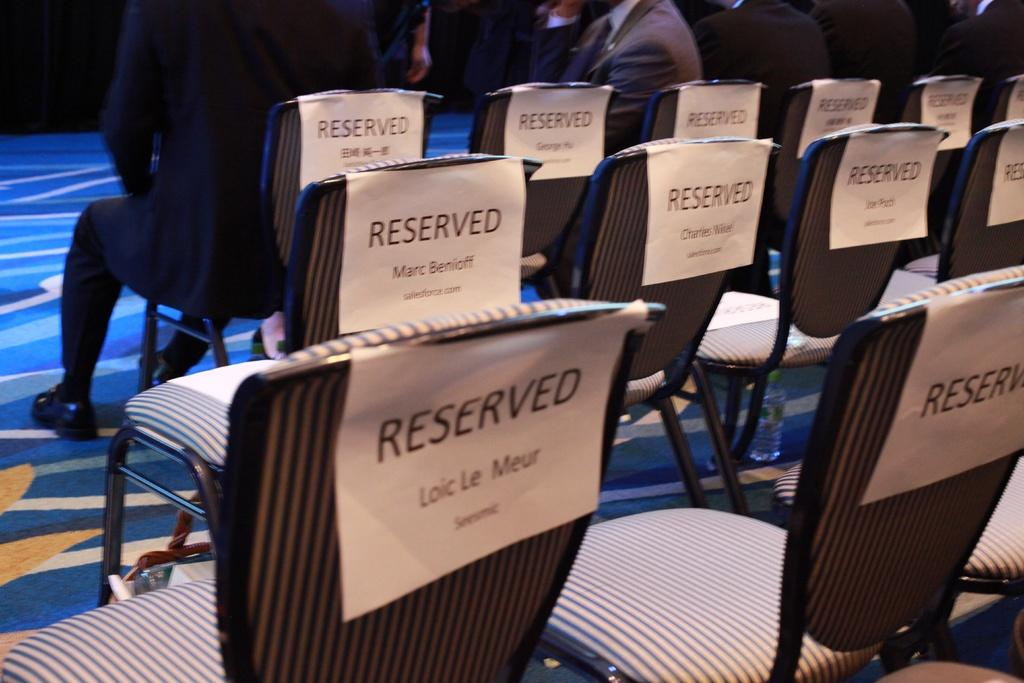<image>
Create a compact narrative representing the image presented. A collection of seats that all have reserved signs on them. 